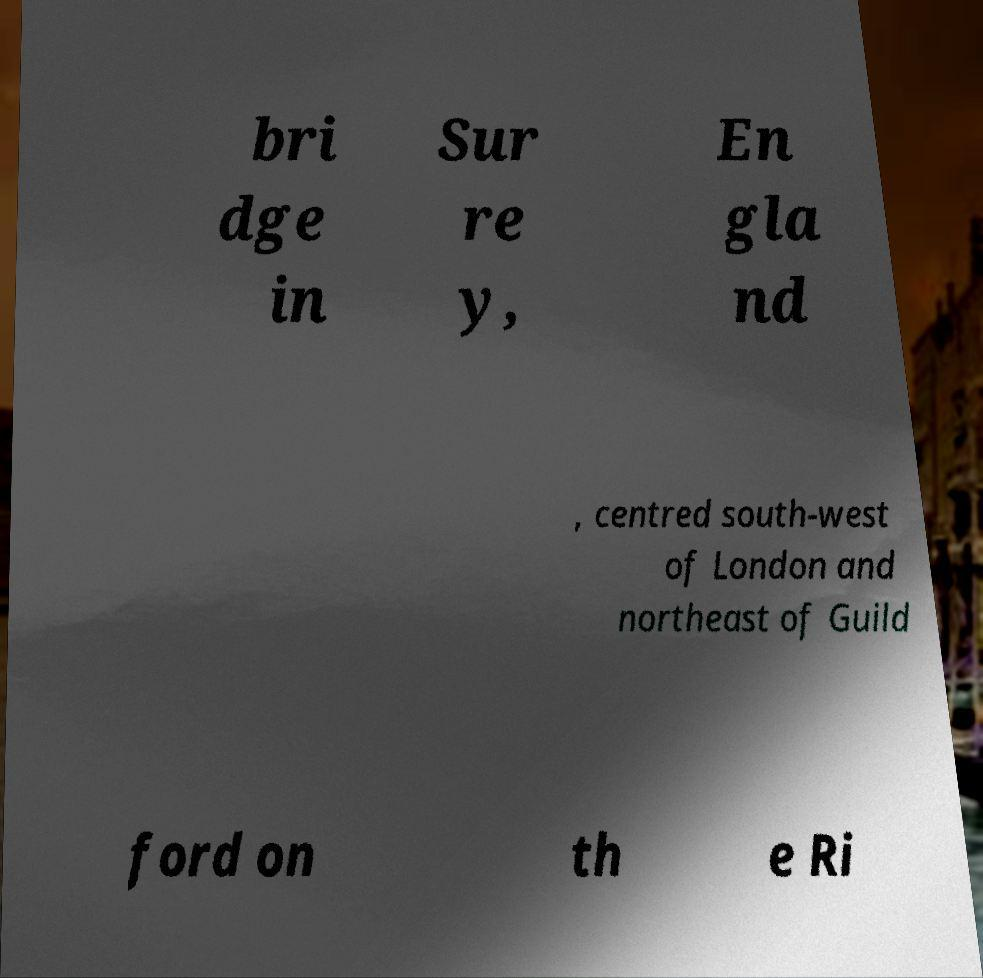Could you assist in decoding the text presented in this image and type it out clearly? bri dge in Sur re y, En gla nd , centred south-west of London and northeast of Guild ford on th e Ri 